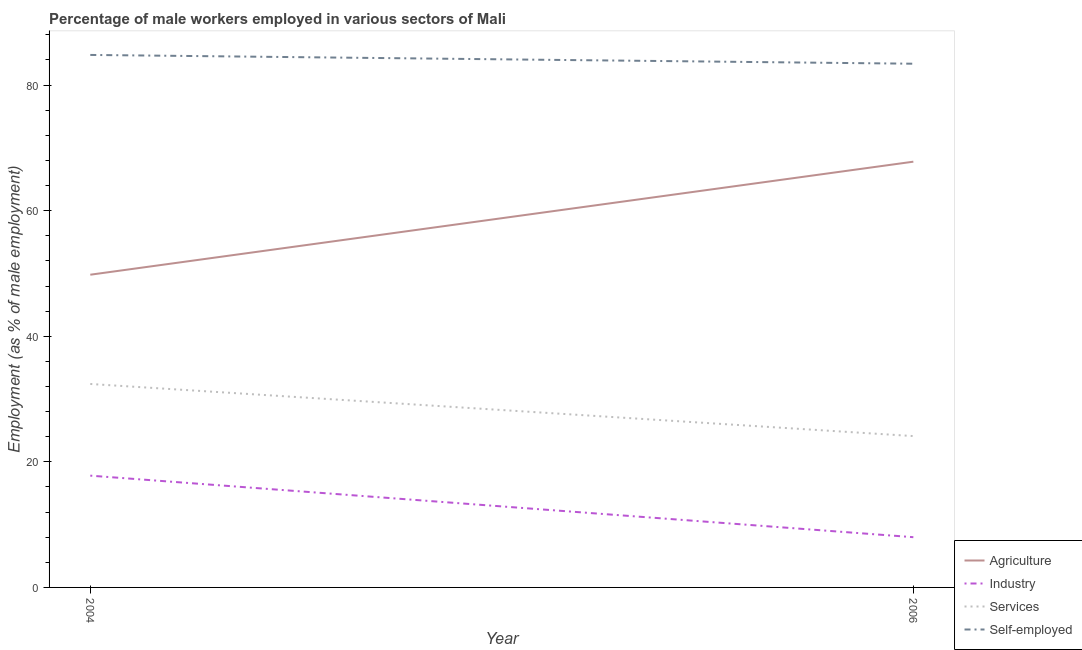How many different coloured lines are there?
Your response must be concise. 4. Does the line corresponding to percentage of male workers in industry intersect with the line corresponding to percentage of male workers in services?
Offer a terse response. No. What is the percentage of male workers in industry in 2006?
Provide a succinct answer. 8. Across all years, what is the maximum percentage of male workers in industry?
Make the answer very short. 17.8. Across all years, what is the minimum percentage of male workers in services?
Your response must be concise. 24.1. In which year was the percentage of male workers in industry maximum?
Give a very brief answer. 2004. In which year was the percentage of self employed male workers minimum?
Your answer should be compact. 2006. What is the total percentage of self employed male workers in the graph?
Your answer should be very brief. 168.2. What is the difference between the percentage of self employed male workers in 2004 and that in 2006?
Your answer should be compact. 1.4. What is the difference between the percentage of male workers in agriculture in 2004 and the percentage of self employed male workers in 2006?
Give a very brief answer. -33.6. What is the average percentage of male workers in services per year?
Your response must be concise. 28.25. In the year 2006, what is the difference between the percentage of self employed male workers and percentage of male workers in agriculture?
Give a very brief answer. 15.6. What is the ratio of the percentage of male workers in industry in 2004 to that in 2006?
Your answer should be compact. 2.22. In how many years, is the percentage of male workers in services greater than the average percentage of male workers in services taken over all years?
Your answer should be very brief. 1. Does the percentage of male workers in agriculture monotonically increase over the years?
Your answer should be compact. Yes. Is the percentage of male workers in services strictly greater than the percentage of male workers in agriculture over the years?
Offer a terse response. No. How many lines are there?
Make the answer very short. 4. How many years are there in the graph?
Offer a very short reply. 2. Are the values on the major ticks of Y-axis written in scientific E-notation?
Provide a short and direct response. No. Does the graph contain any zero values?
Offer a terse response. No. Where does the legend appear in the graph?
Keep it short and to the point. Bottom right. How many legend labels are there?
Ensure brevity in your answer.  4. What is the title of the graph?
Ensure brevity in your answer.  Percentage of male workers employed in various sectors of Mali. Does "HFC gas" appear as one of the legend labels in the graph?
Your answer should be compact. No. What is the label or title of the Y-axis?
Your answer should be very brief. Employment (as % of male employment). What is the Employment (as % of male employment) of Agriculture in 2004?
Make the answer very short. 49.8. What is the Employment (as % of male employment) of Industry in 2004?
Ensure brevity in your answer.  17.8. What is the Employment (as % of male employment) in Services in 2004?
Provide a succinct answer. 32.4. What is the Employment (as % of male employment) of Self-employed in 2004?
Give a very brief answer. 84.8. What is the Employment (as % of male employment) of Agriculture in 2006?
Give a very brief answer. 67.8. What is the Employment (as % of male employment) in Services in 2006?
Ensure brevity in your answer.  24.1. What is the Employment (as % of male employment) in Self-employed in 2006?
Provide a succinct answer. 83.4. Across all years, what is the maximum Employment (as % of male employment) in Agriculture?
Offer a very short reply. 67.8. Across all years, what is the maximum Employment (as % of male employment) of Industry?
Provide a succinct answer. 17.8. Across all years, what is the maximum Employment (as % of male employment) of Services?
Make the answer very short. 32.4. Across all years, what is the maximum Employment (as % of male employment) of Self-employed?
Your answer should be very brief. 84.8. Across all years, what is the minimum Employment (as % of male employment) in Agriculture?
Offer a very short reply. 49.8. Across all years, what is the minimum Employment (as % of male employment) in Services?
Your answer should be compact. 24.1. Across all years, what is the minimum Employment (as % of male employment) in Self-employed?
Your response must be concise. 83.4. What is the total Employment (as % of male employment) of Agriculture in the graph?
Your response must be concise. 117.6. What is the total Employment (as % of male employment) of Industry in the graph?
Give a very brief answer. 25.8. What is the total Employment (as % of male employment) in Services in the graph?
Provide a short and direct response. 56.5. What is the total Employment (as % of male employment) of Self-employed in the graph?
Your answer should be very brief. 168.2. What is the difference between the Employment (as % of male employment) of Agriculture in 2004 and the Employment (as % of male employment) of Industry in 2006?
Offer a very short reply. 41.8. What is the difference between the Employment (as % of male employment) in Agriculture in 2004 and the Employment (as % of male employment) in Services in 2006?
Give a very brief answer. 25.7. What is the difference between the Employment (as % of male employment) of Agriculture in 2004 and the Employment (as % of male employment) of Self-employed in 2006?
Offer a terse response. -33.6. What is the difference between the Employment (as % of male employment) in Industry in 2004 and the Employment (as % of male employment) in Self-employed in 2006?
Your response must be concise. -65.6. What is the difference between the Employment (as % of male employment) of Services in 2004 and the Employment (as % of male employment) of Self-employed in 2006?
Give a very brief answer. -51. What is the average Employment (as % of male employment) in Agriculture per year?
Offer a very short reply. 58.8. What is the average Employment (as % of male employment) of Industry per year?
Make the answer very short. 12.9. What is the average Employment (as % of male employment) of Services per year?
Your answer should be compact. 28.25. What is the average Employment (as % of male employment) in Self-employed per year?
Keep it short and to the point. 84.1. In the year 2004, what is the difference between the Employment (as % of male employment) of Agriculture and Employment (as % of male employment) of Industry?
Your answer should be very brief. 32. In the year 2004, what is the difference between the Employment (as % of male employment) in Agriculture and Employment (as % of male employment) in Self-employed?
Your answer should be very brief. -35. In the year 2004, what is the difference between the Employment (as % of male employment) in Industry and Employment (as % of male employment) in Services?
Provide a succinct answer. -14.6. In the year 2004, what is the difference between the Employment (as % of male employment) in Industry and Employment (as % of male employment) in Self-employed?
Make the answer very short. -67. In the year 2004, what is the difference between the Employment (as % of male employment) in Services and Employment (as % of male employment) in Self-employed?
Offer a terse response. -52.4. In the year 2006, what is the difference between the Employment (as % of male employment) of Agriculture and Employment (as % of male employment) of Industry?
Make the answer very short. 59.8. In the year 2006, what is the difference between the Employment (as % of male employment) of Agriculture and Employment (as % of male employment) of Services?
Ensure brevity in your answer.  43.7. In the year 2006, what is the difference between the Employment (as % of male employment) of Agriculture and Employment (as % of male employment) of Self-employed?
Your answer should be very brief. -15.6. In the year 2006, what is the difference between the Employment (as % of male employment) in Industry and Employment (as % of male employment) in Services?
Your response must be concise. -16.1. In the year 2006, what is the difference between the Employment (as % of male employment) of Industry and Employment (as % of male employment) of Self-employed?
Your response must be concise. -75.4. In the year 2006, what is the difference between the Employment (as % of male employment) in Services and Employment (as % of male employment) in Self-employed?
Offer a very short reply. -59.3. What is the ratio of the Employment (as % of male employment) of Agriculture in 2004 to that in 2006?
Offer a terse response. 0.73. What is the ratio of the Employment (as % of male employment) in Industry in 2004 to that in 2006?
Ensure brevity in your answer.  2.23. What is the ratio of the Employment (as % of male employment) in Services in 2004 to that in 2006?
Keep it short and to the point. 1.34. What is the ratio of the Employment (as % of male employment) of Self-employed in 2004 to that in 2006?
Offer a terse response. 1.02. What is the difference between the highest and the second highest Employment (as % of male employment) in Agriculture?
Your answer should be compact. 18. What is the difference between the highest and the second highest Employment (as % of male employment) in Industry?
Give a very brief answer. 9.8. What is the difference between the highest and the second highest Employment (as % of male employment) of Services?
Offer a very short reply. 8.3. What is the difference between the highest and the lowest Employment (as % of male employment) of Agriculture?
Your response must be concise. 18. 